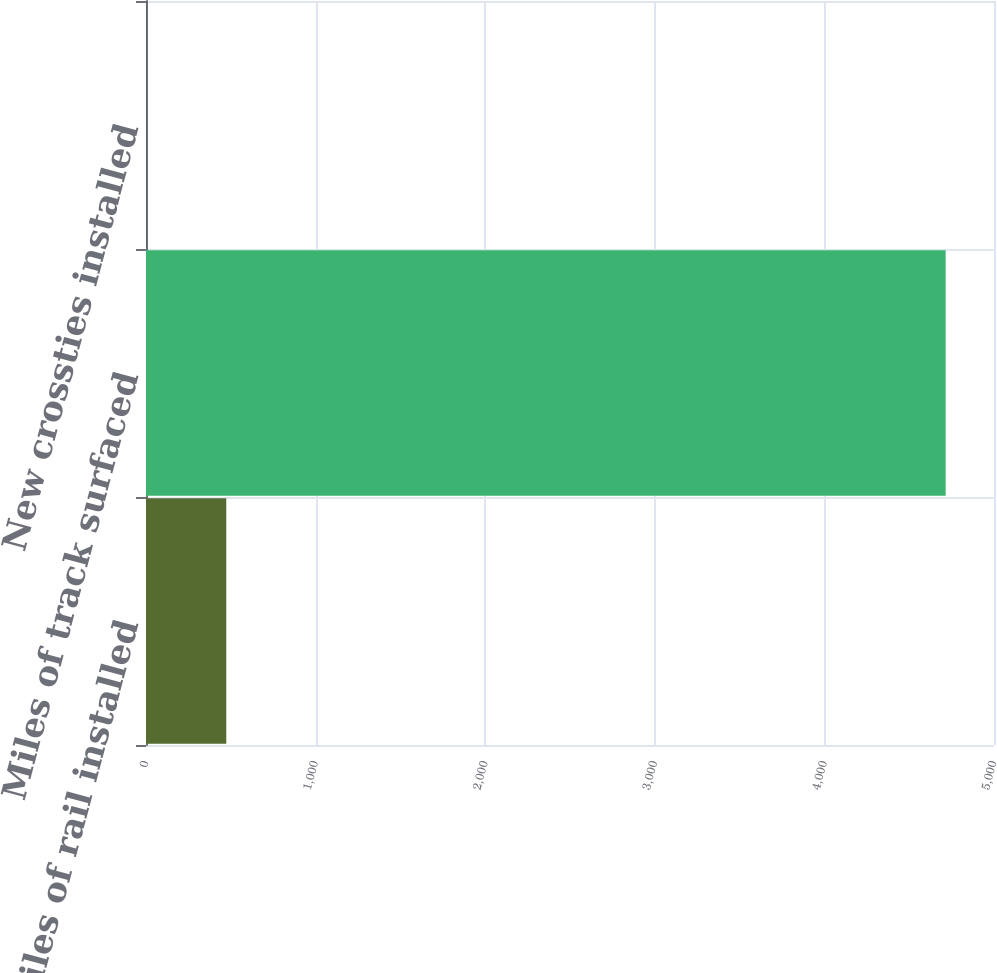<chart> <loc_0><loc_0><loc_500><loc_500><bar_chart><fcel>Track miles of rail installed<fcel>Miles of track surfaced<fcel>New crossties installed<nl><fcel>473.3<fcel>4715<fcel>2<nl></chart> 